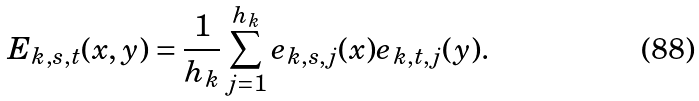<formula> <loc_0><loc_0><loc_500><loc_500>E _ { k , s , t } ( x , y ) = \frac { 1 } { h _ { k } } \sum _ { j = 1 } ^ { h _ { k } } e _ { k , s , j } ( x ) e _ { k , t , j } ( y ) .</formula> 